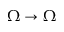<formula> <loc_0><loc_0><loc_500><loc_500>\Omega \to \Omega</formula> 